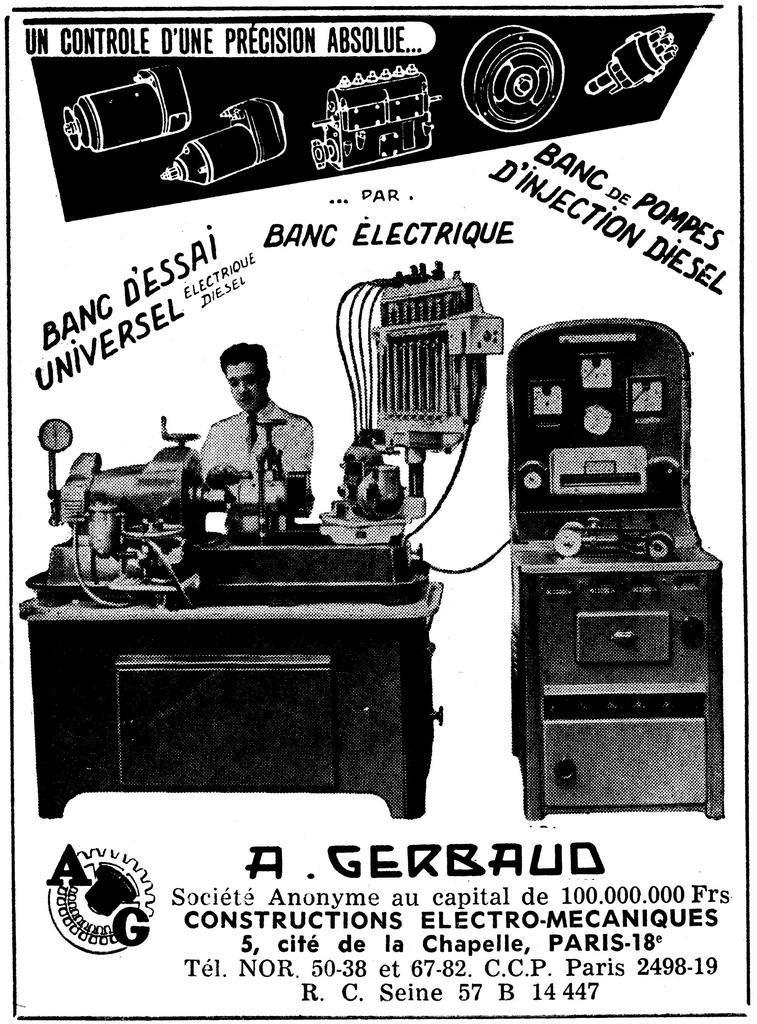Describe this image in one or two sentences. In the image we can see there is a poster on which there is a machine and there is a person standing near the machine. There are machine equipments on the poster and the matter is written on the poster. The image is in black and white colour. 